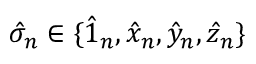Convert formula to latex. <formula><loc_0><loc_0><loc_500><loc_500>\hat { \sigma } _ { n } \in \{ \hat { 1 } _ { n } , \hat { x } _ { n } , \hat { y } _ { n } , \hat { z } _ { n } \}</formula> 